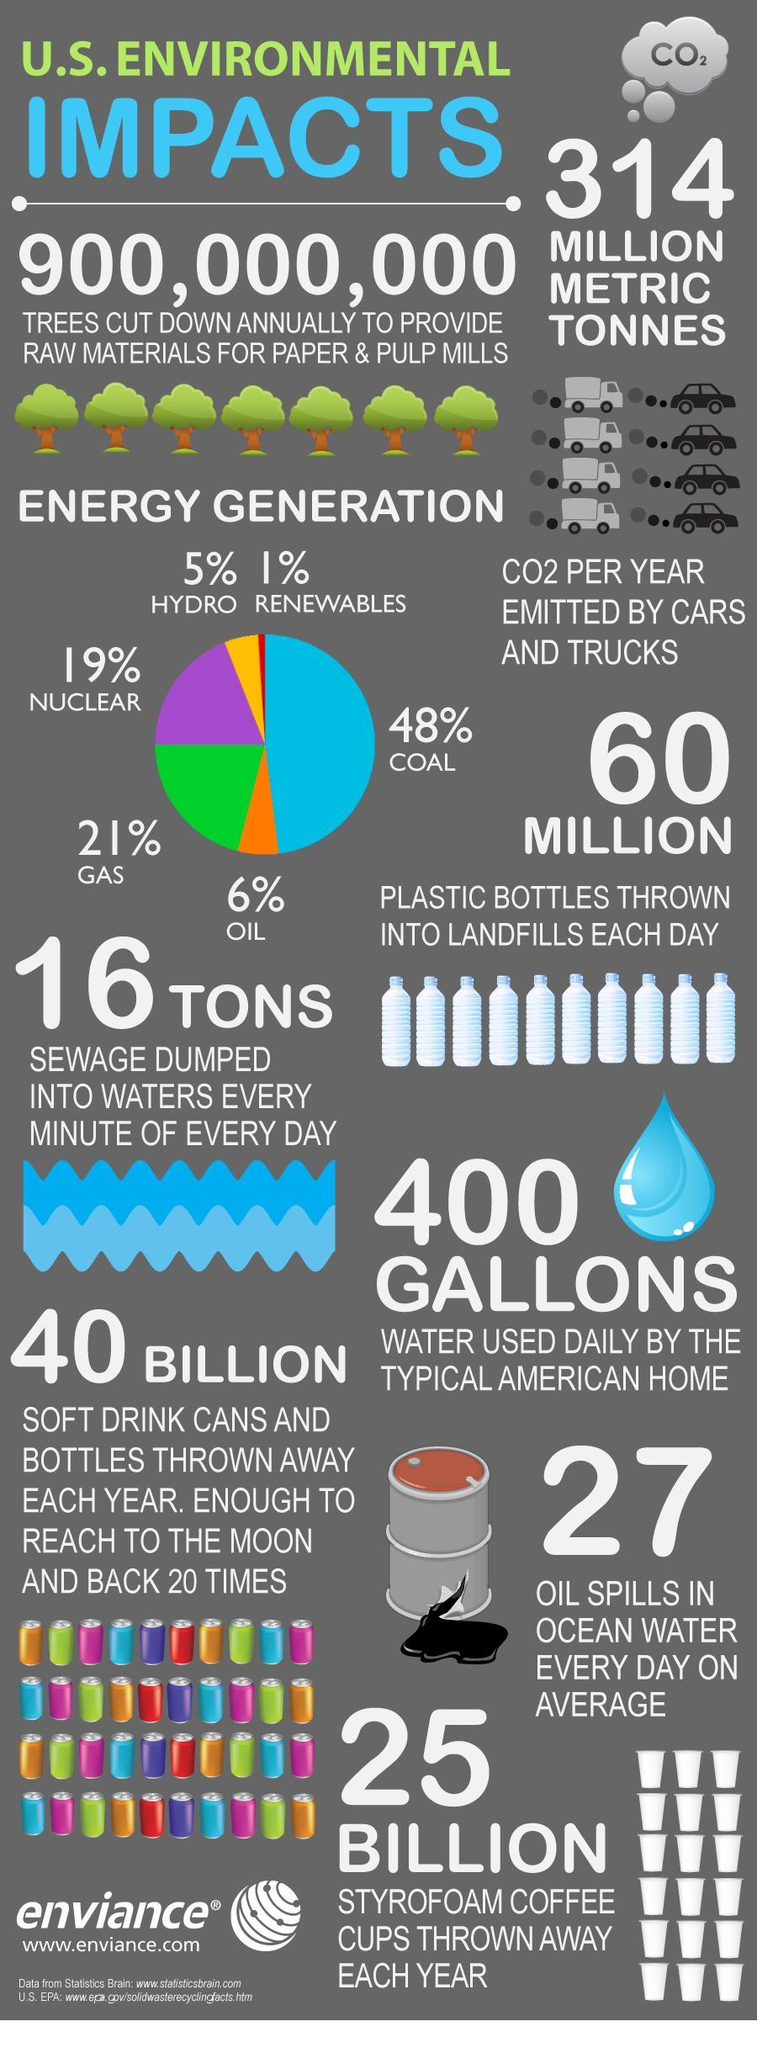how many billion soft drink cans and styrofoam coffee cups thrown away each year
Answer the question with a short phrase. 65 what is the CO2 per year emitted by cars and trucks 314 million metric tonnes what is the name of the gas mentioned CO2 how much percentage energy does gas and oil generate 27 what generates the maximum energy coal what percentage energy generation by hydro and renewables 6 what is enough to reach to the moon and back 20 times 40 billion soft drink cans and bottles 